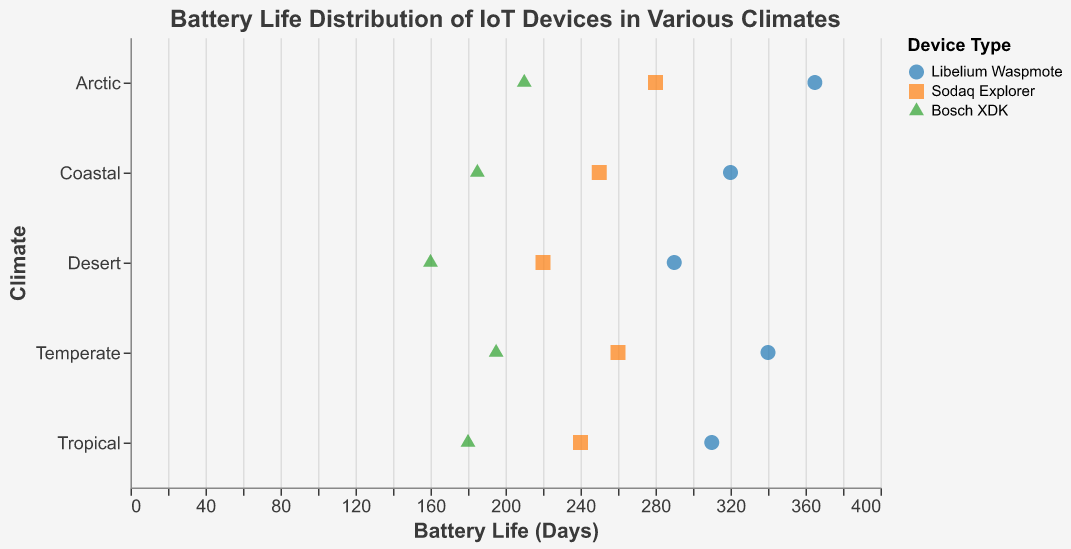How many devices have a battery life greater than 300 days in total? Count the number of points on the x-axis greater than 300 days; each point represents a device in a climate.
Answer: 4 Which climate has the device with the highest battery life? Identify the climate(s) where the point is farthest to the right on the x-axis. The farthest point to the right is 365 days.
Answer: Arctic What is the range of battery life values for devices in the Desert climate? Find the maximum and minimum battery life values for devices in the Desert climate. The maximum is 290 days and the minimum is 160 days.
Answer: 160 to 290 days Which device type generally performs best in terms of battery life? Compare the battery life of each device type (color shapes) across all climates. Libelium Waspmote consistently shows higher values.
Answer: Libelium Waspmote How does the battery life of Bosch XDK in the Coastal climate compare with other climates? Locate the Bosch XDK points for Coastal and compare their battery life values to those in Arctic, Tropical, Desert, and Temperate. Coastal Bosch XDK at 185 days is better only than Desert (160 days).
Answer: Lower than Arctic, Tropical, and Temperate; higher than Desert What is the average battery life of Sodaq Explorer across all climates? Calculate the average by summing battery lives for Sodaq Explorer and dividing by the number of climates: (280 + 240 + 220 + 260 + 250) / 5 = 1250 / 5 = 250 days.
Answer: 250 days Are there any climates where all devices have battery lives below 300 days? Check each climate's devices and see if all have values below 300 days. Both Tropical and Desert fulfill this condition.
Answer: Tropical, Desert What is the difference in battery life between the best and worst-performing devices in the Temperate climate? Identify the maximum and minimum values for Temperate climate: 340 days and 195 days. Subtract them to get the difference: 340 - 195 = 145 days.
Answer: 145 days In which climate does Sodaq Explorer have its lowest battery life? Compare the battery life of Sodaq Explorer across all climates. The lowest battery life for Sodaq Explorer is 220 days in the Desert climate.
Answer: Desert 